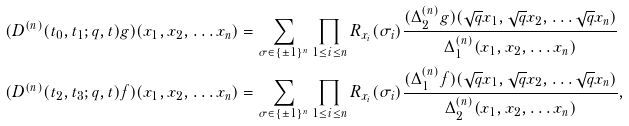<formula> <loc_0><loc_0><loc_500><loc_500>( D ^ { ( n ) } ( t _ { 0 } , t _ { 1 } ; q , t ) g ) ( x _ { 1 } , x _ { 2 } , \dots x _ { n } ) & = \sum _ { \sigma \in \{ \pm 1 \} ^ { n } } \prod _ { 1 \leq i \leq n } R _ { x _ { i } } ( \sigma _ { i } ) \frac { ( \Delta ^ { ( n ) } _ { 2 } g ) ( \sqrt { q } x _ { 1 } , \sqrt { q } x _ { 2 } , \dots \sqrt { q } x _ { n } ) } { \Delta ^ { ( n ) } _ { 1 } ( x _ { 1 } , x _ { 2 } , \dots x _ { n } ) } \\ ( D ^ { ( n ) } ( t _ { 2 } , t _ { 3 } ; q , t ) f ) ( x _ { 1 } , x _ { 2 } , \dots x _ { n } ) & = \sum _ { \sigma \in \{ \pm 1 \} ^ { n } } \prod _ { 1 \leq i \leq n } R _ { x _ { i } } ( \sigma _ { i } ) \frac { ( \Delta ^ { ( n ) } _ { 1 } f ) ( \sqrt { q } x _ { 1 } , \sqrt { q } x _ { 2 } , \dots \sqrt { q } x _ { n } ) } { \Delta ^ { ( n ) } _ { 2 } ( x _ { 1 } , x _ { 2 } , \dots x _ { n } ) } ,</formula> 